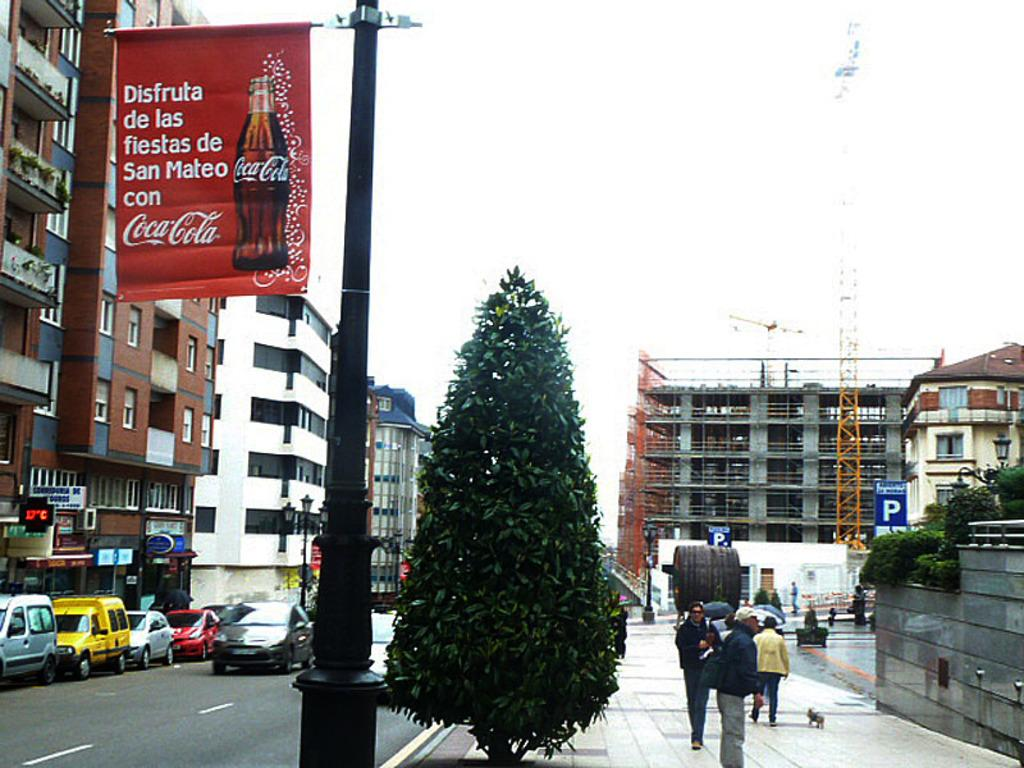<image>
Summarize the visual content of the image. An ad for Coca-Cola hanging from a post near a street in San Mateo. 